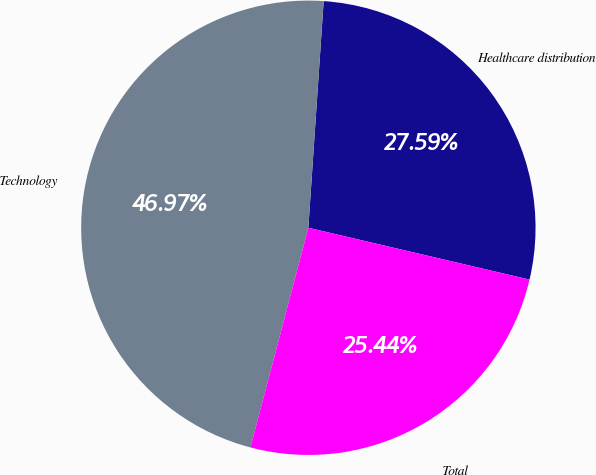Convert chart. <chart><loc_0><loc_0><loc_500><loc_500><pie_chart><fcel>Healthcare distribution<fcel>Technology<fcel>Total<nl><fcel>27.59%<fcel>46.97%<fcel>25.44%<nl></chart> 